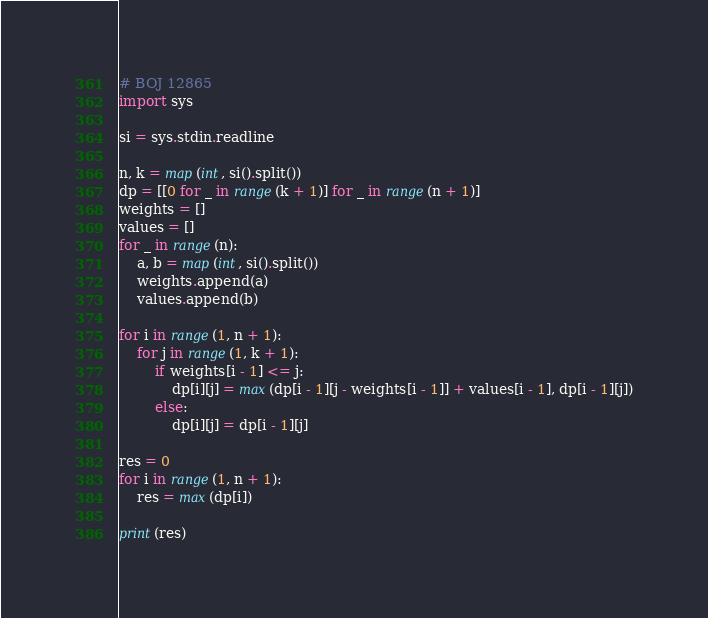<code> <loc_0><loc_0><loc_500><loc_500><_Python_># BOJ 12865
import sys

si = sys.stdin.readline

n, k = map(int, si().split())
dp = [[0 for _ in range(k + 1)] for _ in range(n + 1)]
weights = []
values = []
for _ in range(n):
    a, b = map(int, si().split())
    weights.append(a)
    values.append(b)

for i in range(1, n + 1):
    for j in range(1, k + 1):
        if weights[i - 1] <= j:
            dp[i][j] = max(dp[i - 1][j - weights[i - 1]] + values[i - 1], dp[i - 1][j])
        else:
            dp[i][j] = dp[i - 1][j]

res = 0
for i in range(1, n + 1):
    res = max(dp[i])

print(res)
</code> 